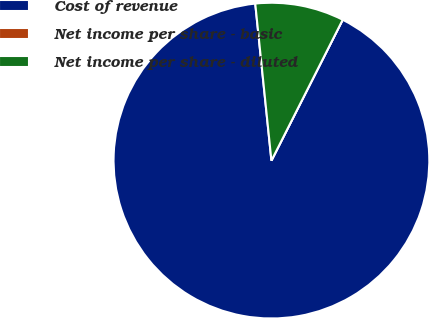Convert chart. <chart><loc_0><loc_0><loc_500><loc_500><pie_chart><fcel>Cost of revenue<fcel>Net income per share - basic<fcel>Net income per share - diluted<nl><fcel>90.91%<fcel>0.0%<fcel>9.09%<nl></chart> 